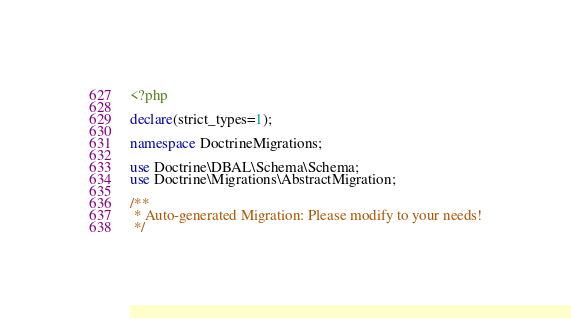Convert code to text. <code><loc_0><loc_0><loc_500><loc_500><_PHP_><?php

declare(strict_types=1);

namespace DoctrineMigrations;

use Doctrine\DBAL\Schema\Schema;
use Doctrine\Migrations\AbstractMigration;

/**
 * Auto-generated Migration: Please modify to your needs!
 */</code> 